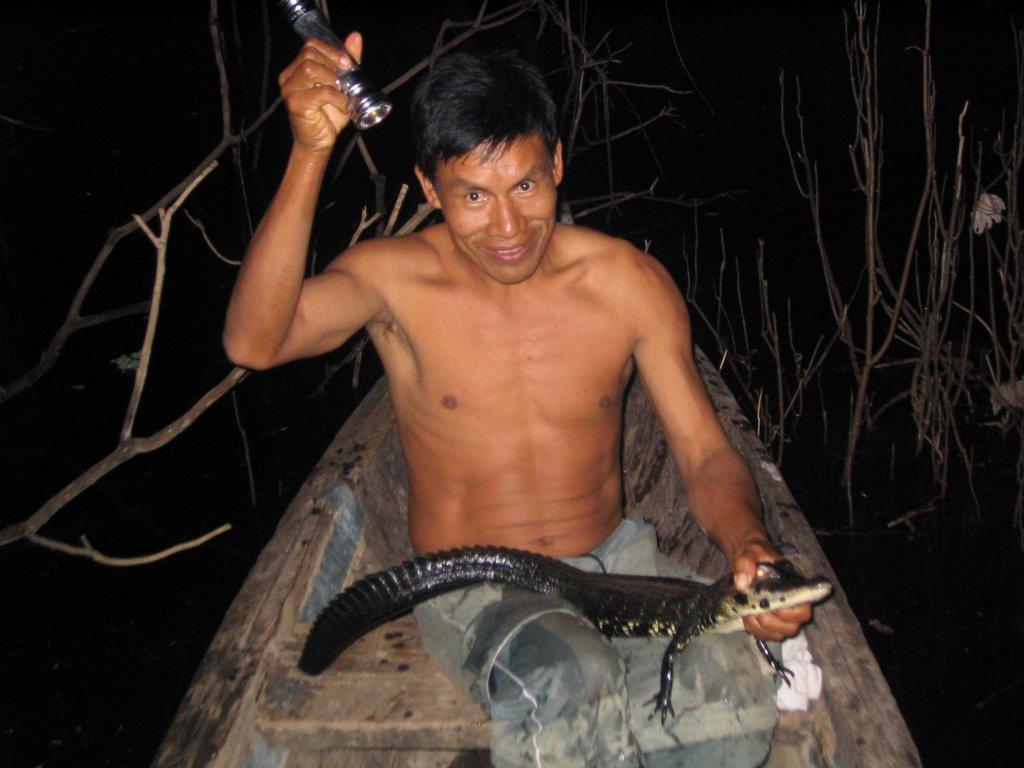Describe this image in one or two sentences. In this image I can see a person holding an animal and something. Back I can see dry stems and black background. 